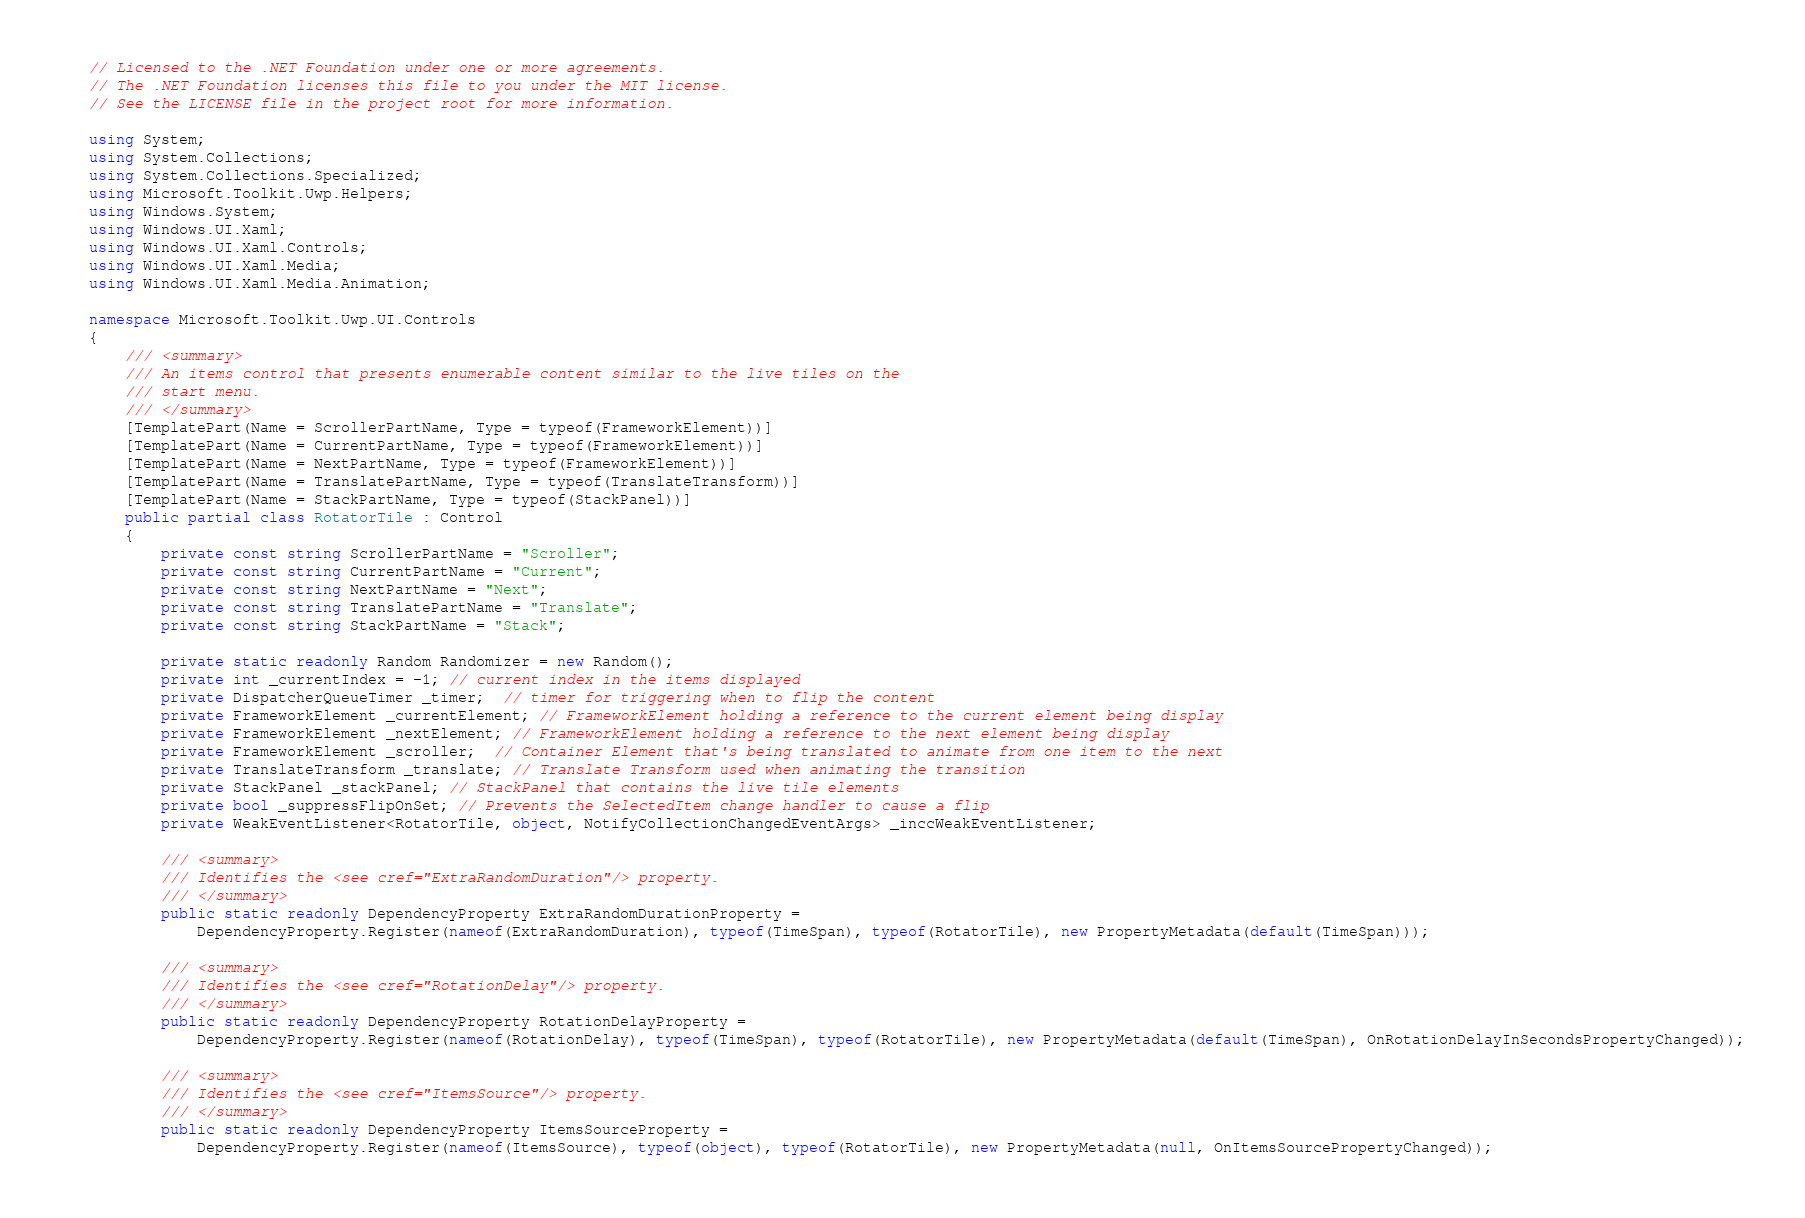Convert code to text. <code><loc_0><loc_0><loc_500><loc_500><_C#_>// Licensed to the .NET Foundation under one or more agreements.
// The .NET Foundation licenses this file to you under the MIT license.
// See the LICENSE file in the project root for more information.

using System;
using System.Collections;
using System.Collections.Specialized;
using Microsoft.Toolkit.Uwp.Helpers;
using Windows.System;
using Windows.UI.Xaml;
using Windows.UI.Xaml.Controls;
using Windows.UI.Xaml.Media;
using Windows.UI.Xaml.Media.Animation;

namespace Microsoft.Toolkit.Uwp.UI.Controls
{
    /// <summary>
    /// An items control that presents enumerable content similar to the live tiles on the
    /// start menu.
    /// </summary>
    [TemplatePart(Name = ScrollerPartName, Type = typeof(FrameworkElement))]
    [TemplatePart(Name = CurrentPartName, Type = typeof(FrameworkElement))]
    [TemplatePart(Name = NextPartName, Type = typeof(FrameworkElement))]
    [TemplatePart(Name = TranslatePartName, Type = typeof(TranslateTransform))]
    [TemplatePart(Name = StackPartName, Type = typeof(StackPanel))]
    public partial class RotatorTile : Control
    {
        private const string ScrollerPartName = "Scroller";
        private const string CurrentPartName = "Current";
        private const string NextPartName = "Next";
        private const string TranslatePartName = "Translate";
        private const string StackPartName = "Stack";

        private static readonly Random Randomizer = new Random();
        private int _currentIndex = -1; // current index in the items displayed
        private DispatcherQueueTimer _timer;  // timer for triggering when to flip the content
        private FrameworkElement _currentElement; // FrameworkElement holding a reference to the current element being display
        private FrameworkElement _nextElement; // FrameworkElement holding a reference to the next element being display
        private FrameworkElement _scroller;  // Container Element that's being translated to animate from one item to the next
        private TranslateTransform _translate; // Translate Transform used when animating the transition
        private StackPanel _stackPanel; // StackPanel that contains the live tile elements
        private bool _suppressFlipOnSet; // Prevents the SelectedItem change handler to cause a flip
        private WeakEventListener<RotatorTile, object, NotifyCollectionChangedEventArgs> _inccWeakEventListener;

        /// <summary>
        /// Identifies the <see cref="ExtraRandomDuration"/> property.
        /// </summary>
        public static readonly DependencyProperty ExtraRandomDurationProperty =
            DependencyProperty.Register(nameof(ExtraRandomDuration), typeof(TimeSpan), typeof(RotatorTile), new PropertyMetadata(default(TimeSpan)));

        /// <summary>
        /// Identifies the <see cref="RotationDelay"/> property.
        /// </summary>
        public static readonly DependencyProperty RotationDelayProperty =
            DependencyProperty.Register(nameof(RotationDelay), typeof(TimeSpan), typeof(RotatorTile), new PropertyMetadata(default(TimeSpan), OnRotationDelayInSecondsPropertyChanged));

        /// <summary>
        /// Identifies the <see cref="ItemsSource"/> property.
        /// </summary>
        public static readonly DependencyProperty ItemsSourceProperty =
            DependencyProperty.Register(nameof(ItemsSource), typeof(object), typeof(RotatorTile), new PropertyMetadata(null, OnItemsSourcePropertyChanged));
</code> 